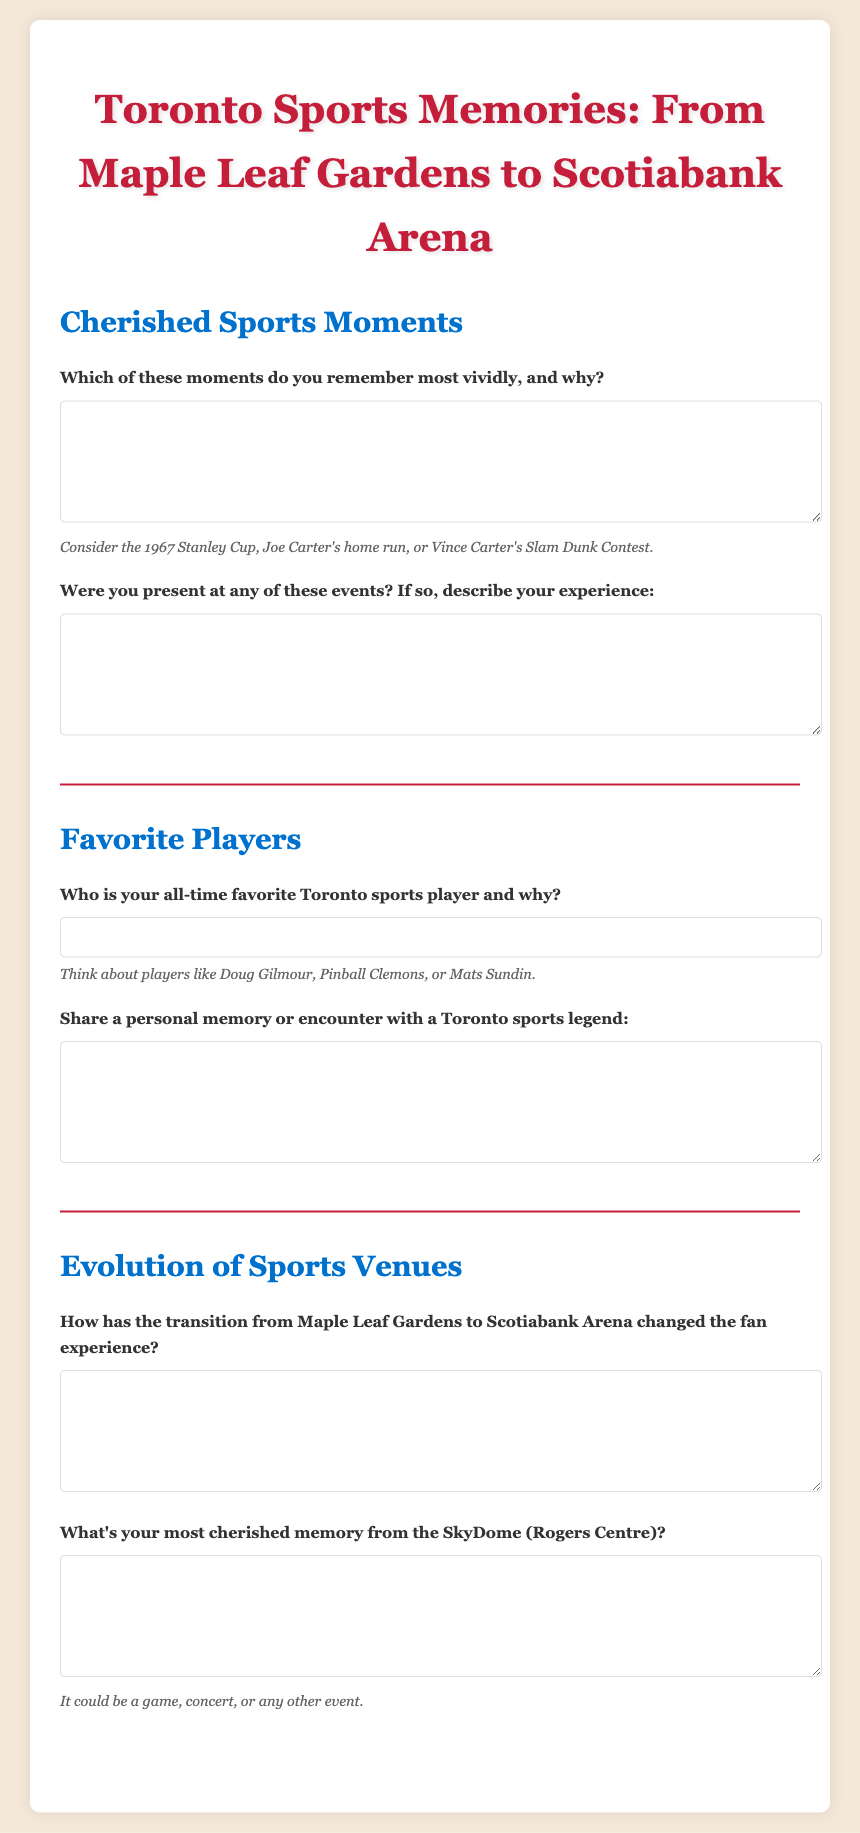What are the two main sports venues mentioned in the document? The document discusses the transition from Maple Leaf Gardens to Scotiabank Arena.
Answer: Maple Leaf Gardens, Scotiabank Arena What year is referenced in the context of the Stanley Cup? The questionnaire mentions the 1967 Stanley Cup as a significant moment.
Answer: 1967 Who is a notable player mentioned as an example in the favorite players section? The document lists Doug Gilmour, Pinball Clemons, and Mats Sundin as examples of favorite players.
Answer: Doug Gilmour What type of personal memory is requested about Toronto sports legends? Participants are asked to share a personal memory or encounter with a Toronto sports legend.
Answer: Personal memory What does the hint suggest participants consider for cherished sports moments? The hint prompts participants to think about significant moments like Joe Carter's home run or Vince Carter's Slam Dunk Contest.
Answer: Joe Carter's home run What is the purpose of the questionnaire? The questionnaire aims to collect Toronto sports memories from individuals regarding cherished moments, favorite players, and venue evolution.
Answer: Collect memories 